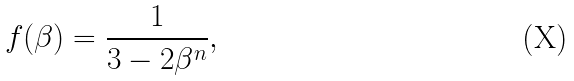Convert formula to latex. <formula><loc_0><loc_0><loc_500><loc_500>f ( \beta ) = \frac { 1 } { 3 - 2 \beta ^ { n } } ,</formula> 